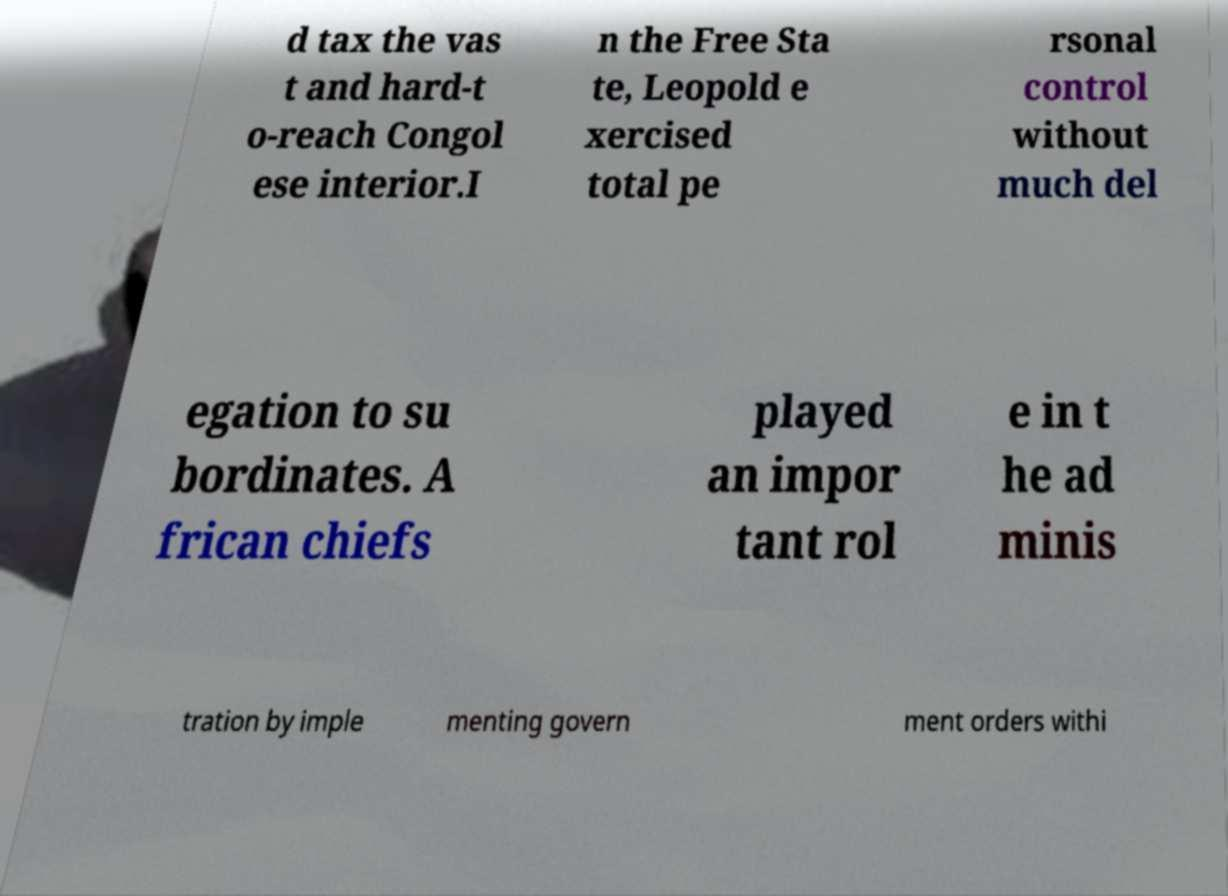There's text embedded in this image that I need extracted. Can you transcribe it verbatim? d tax the vas t and hard-t o-reach Congol ese interior.I n the Free Sta te, Leopold e xercised total pe rsonal control without much del egation to su bordinates. A frican chiefs played an impor tant rol e in t he ad minis tration by imple menting govern ment orders withi 